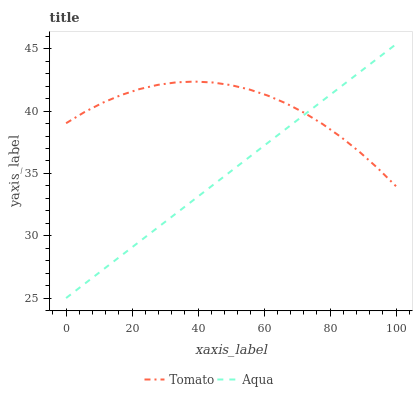Does Aqua have the minimum area under the curve?
Answer yes or no. Yes. Does Tomato have the maximum area under the curve?
Answer yes or no. Yes. Does Aqua have the maximum area under the curve?
Answer yes or no. No. Is Aqua the smoothest?
Answer yes or no. Yes. Is Tomato the roughest?
Answer yes or no. Yes. Is Aqua the roughest?
Answer yes or no. No. Does Aqua have the lowest value?
Answer yes or no. Yes. Does Aqua have the highest value?
Answer yes or no. Yes. Does Tomato intersect Aqua?
Answer yes or no. Yes. Is Tomato less than Aqua?
Answer yes or no. No. Is Tomato greater than Aqua?
Answer yes or no. No. 